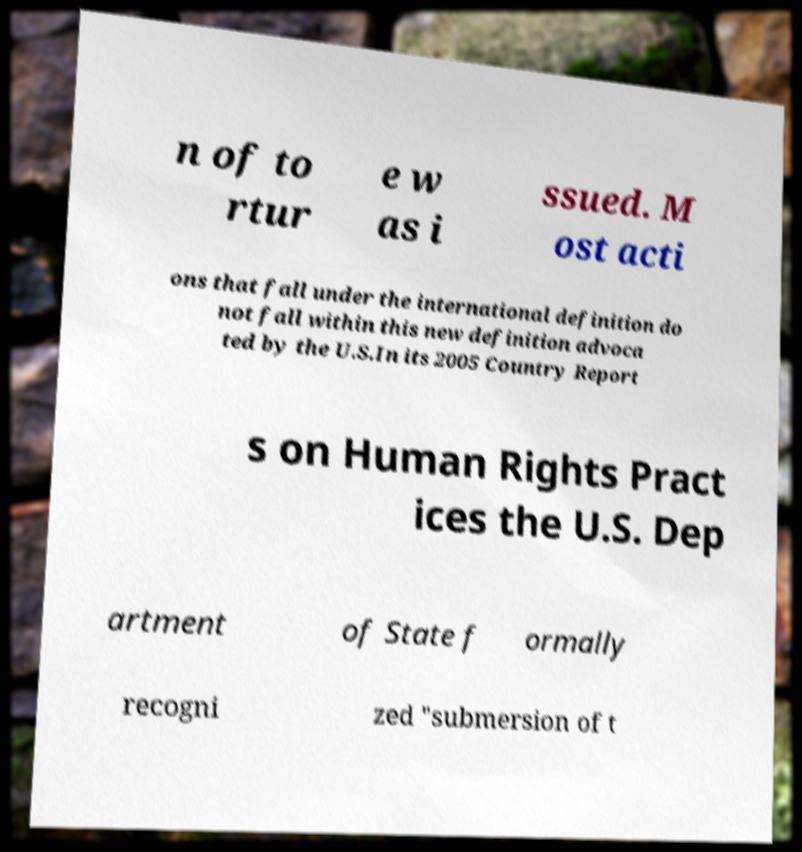Can you accurately transcribe the text from the provided image for me? n of to rtur e w as i ssued. M ost acti ons that fall under the international definition do not fall within this new definition advoca ted by the U.S.In its 2005 Country Report s on Human Rights Pract ices the U.S. Dep artment of State f ormally recogni zed "submersion of t 